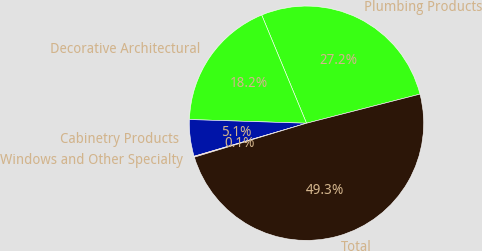Convert chart to OTSL. <chart><loc_0><loc_0><loc_500><loc_500><pie_chart><fcel>Plumbing Products<fcel>Decorative Architectural<fcel>Cabinetry Products<fcel>Windows and Other Specialty<fcel>Total<nl><fcel>27.25%<fcel>18.25%<fcel>5.05%<fcel>0.13%<fcel>49.32%<nl></chart> 